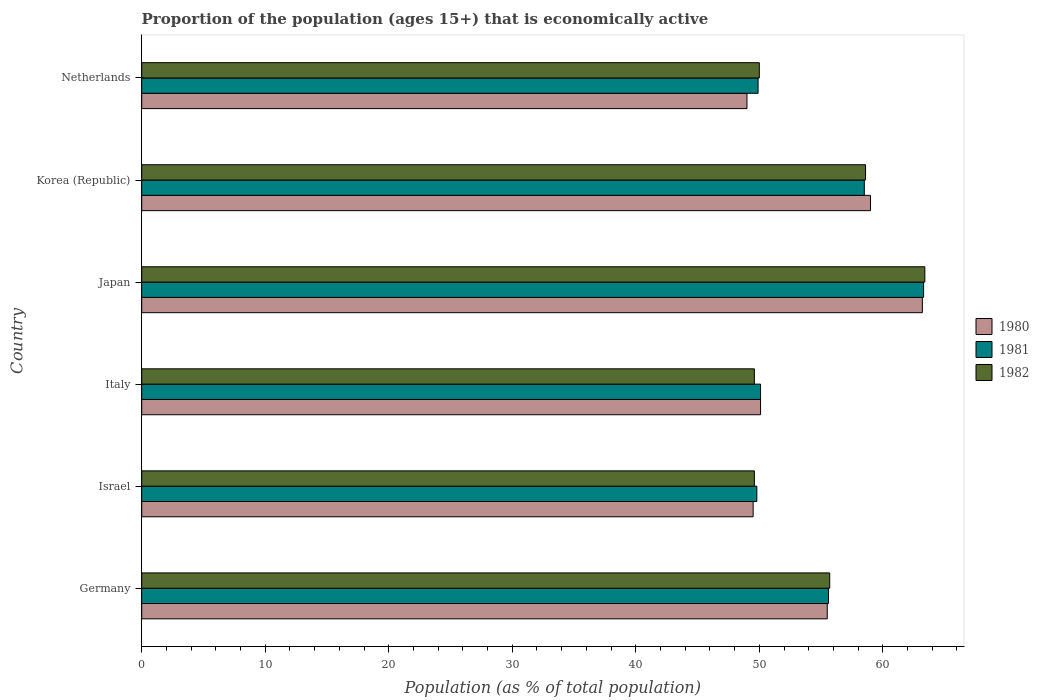How many different coloured bars are there?
Ensure brevity in your answer.  3. Are the number of bars on each tick of the Y-axis equal?
Offer a terse response. Yes. How many bars are there on the 3rd tick from the top?
Your answer should be compact. 3. What is the label of the 5th group of bars from the top?
Offer a terse response. Israel. In how many cases, is the number of bars for a given country not equal to the number of legend labels?
Provide a succinct answer. 0. What is the proportion of the population that is economically active in 1980 in Israel?
Provide a succinct answer. 49.5. Across all countries, what is the maximum proportion of the population that is economically active in 1981?
Provide a succinct answer. 63.3. Across all countries, what is the minimum proportion of the population that is economically active in 1981?
Your answer should be very brief. 49.8. In which country was the proportion of the population that is economically active in 1981 maximum?
Your answer should be compact. Japan. What is the total proportion of the population that is economically active in 1981 in the graph?
Provide a short and direct response. 327.2. What is the difference between the proportion of the population that is economically active in 1981 in Italy and that in Japan?
Give a very brief answer. -13.2. What is the difference between the proportion of the population that is economically active in 1981 in Netherlands and the proportion of the population that is economically active in 1980 in Italy?
Your answer should be very brief. -0.2. What is the average proportion of the population that is economically active in 1982 per country?
Offer a terse response. 54.48. What is the difference between the proportion of the population that is economically active in 1982 and proportion of the population that is economically active in 1980 in Japan?
Provide a succinct answer. 0.2. What is the ratio of the proportion of the population that is economically active in 1982 in Italy to that in Korea (Republic)?
Your answer should be compact. 0.85. Is the difference between the proportion of the population that is economically active in 1982 in Germany and Israel greater than the difference between the proportion of the population that is economically active in 1980 in Germany and Israel?
Your answer should be very brief. Yes. What is the difference between the highest and the second highest proportion of the population that is economically active in 1982?
Your answer should be very brief. 4.8. What is the difference between the highest and the lowest proportion of the population that is economically active in 1981?
Your answer should be very brief. 13.5. In how many countries, is the proportion of the population that is economically active in 1982 greater than the average proportion of the population that is economically active in 1982 taken over all countries?
Keep it short and to the point. 3. Is it the case that in every country, the sum of the proportion of the population that is economically active in 1980 and proportion of the population that is economically active in 1982 is greater than the proportion of the population that is economically active in 1981?
Provide a short and direct response. Yes. How many bars are there?
Provide a short and direct response. 18. How many countries are there in the graph?
Ensure brevity in your answer.  6. What is the difference between two consecutive major ticks on the X-axis?
Your answer should be compact. 10. Are the values on the major ticks of X-axis written in scientific E-notation?
Provide a short and direct response. No. How are the legend labels stacked?
Offer a very short reply. Vertical. What is the title of the graph?
Your answer should be compact. Proportion of the population (ages 15+) that is economically active. What is the label or title of the X-axis?
Make the answer very short. Population (as % of total population). What is the Population (as % of total population) in 1980 in Germany?
Offer a very short reply. 55.5. What is the Population (as % of total population) of 1981 in Germany?
Offer a very short reply. 55.6. What is the Population (as % of total population) in 1982 in Germany?
Provide a succinct answer. 55.7. What is the Population (as % of total population) of 1980 in Israel?
Keep it short and to the point. 49.5. What is the Population (as % of total population) in 1981 in Israel?
Offer a very short reply. 49.8. What is the Population (as % of total population) in 1982 in Israel?
Give a very brief answer. 49.6. What is the Population (as % of total population) of 1980 in Italy?
Ensure brevity in your answer.  50.1. What is the Population (as % of total population) of 1981 in Italy?
Make the answer very short. 50.1. What is the Population (as % of total population) in 1982 in Italy?
Provide a short and direct response. 49.6. What is the Population (as % of total population) of 1980 in Japan?
Keep it short and to the point. 63.2. What is the Population (as % of total population) in 1981 in Japan?
Provide a short and direct response. 63.3. What is the Population (as % of total population) in 1982 in Japan?
Give a very brief answer. 63.4. What is the Population (as % of total population) in 1980 in Korea (Republic)?
Your answer should be compact. 59. What is the Population (as % of total population) of 1981 in Korea (Republic)?
Your response must be concise. 58.5. What is the Population (as % of total population) in 1982 in Korea (Republic)?
Ensure brevity in your answer.  58.6. What is the Population (as % of total population) of 1980 in Netherlands?
Ensure brevity in your answer.  49. What is the Population (as % of total population) of 1981 in Netherlands?
Your response must be concise. 49.9. Across all countries, what is the maximum Population (as % of total population) in 1980?
Provide a succinct answer. 63.2. Across all countries, what is the maximum Population (as % of total population) in 1981?
Give a very brief answer. 63.3. Across all countries, what is the maximum Population (as % of total population) in 1982?
Give a very brief answer. 63.4. Across all countries, what is the minimum Population (as % of total population) in 1981?
Ensure brevity in your answer.  49.8. Across all countries, what is the minimum Population (as % of total population) of 1982?
Make the answer very short. 49.6. What is the total Population (as % of total population) in 1980 in the graph?
Keep it short and to the point. 326.3. What is the total Population (as % of total population) in 1981 in the graph?
Provide a short and direct response. 327.2. What is the total Population (as % of total population) in 1982 in the graph?
Offer a terse response. 326.9. What is the difference between the Population (as % of total population) in 1980 in Germany and that in Israel?
Provide a succinct answer. 6. What is the difference between the Population (as % of total population) of 1981 in Germany and that in Israel?
Ensure brevity in your answer.  5.8. What is the difference between the Population (as % of total population) in 1981 in Germany and that in Italy?
Your answer should be compact. 5.5. What is the difference between the Population (as % of total population) in 1982 in Germany and that in Italy?
Your answer should be very brief. 6.1. What is the difference between the Population (as % of total population) of 1981 in Germany and that in Japan?
Your response must be concise. -7.7. What is the difference between the Population (as % of total population) in 1980 in Germany and that in Korea (Republic)?
Keep it short and to the point. -3.5. What is the difference between the Population (as % of total population) in 1982 in Germany and that in Netherlands?
Your answer should be compact. 5.7. What is the difference between the Population (as % of total population) in 1981 in Israel and that in Italy?
Offer a very short reply. -0.3. What is the difference between the Population (as % of total population) of 1982 in Israel and that in Italy?
Give a very brief answer. 0. What is the difference between the Population (as % of total population) in 1980 in Israel and that in Japan?
Your answer should be compact. -13.7. What is the difference between the Population (as % of total population) of 1981 in Israel and that in Japan?
Your response must be concise. -13.5. What is the difference between the Population (as % of total population) of 1980 in Israel and that in Korea (Republic)?
Provide a short and direct response. -9.5. What is the difference between the Population (as % of total population) of 1981 in Israel and that in Korea (Republic)?
Ensure brevity in your answer.  -8.7. What is the difference between the Population (as % of total population) in 1980 in Israel and that in Netherlands?
Your response must be concise. 0.5. What is the difference between the Population (as % of total population) of 1981 in Israel and that in Netherlands?
Ensure brevity in your answer.  -0.1. What is the difference between the Population (as % of total population) in 1982 in Israel and that in Netherlands?
Offer a terse response. -0.4. What is the difference between the Population (as % of total population) of 1981 in Italy and that in Japan?
Give a very brief answer. -13.2. What is the difference between the Population (as % of total population) of 1982 in Italy and that in Japan?
Provide a short and direct response. -13.8. What is the difference between the Population (as % of total population) of 1980 in Italy and that in Netherlands?
Your answer should be compact. 1.1. What is the difference between the Population (as % of total population) in 1981 in Italy and that in Netherlands?
Your answer should be compact. 0.2. What is the difference between the Population (as % of total population) of 1980 in Korea (Republic) and that in Netherlands?
Your answer should be compact. 10. What is the difference between the Population (as % of total population) in 1982 in Korea (Republic) and that in Netherlands?
Provide a succinct answer. 8.6. What is the difference between the Population (as % of total population) in 1980 in Germany and the Population (as % of total population) in 1982 in Israel?
Make the answer very short. 5.9. What is the difference between the Population (as % of total population) in 1980 in Germany and the Population (as % of total population) in 1981 in Italy?
Your answer should be compact. 5.4. What is the difference between the Population (as % of total population) of 1980 in Germany and the Population (as % of total population) of 1982 in Japan?
Your answer should be compact. -7.9. What is the difference between the Population (as % of total population) in 1980 in Germany and the Population (as % of total population) in 1981 in Korea (Republic)?
Give a very brief answer. -3. What is the difference between the Population (as % of total population) of 1980 in Germany and the Population (as % of total population) of 1982 in Korea (Republic)?
Offer a very short reply. -3.1. What is the difference between the Population (as % of total population) of 1980 in Germany and the Population (as % of total population) of 1982 in Netherlands?
Your answer should be very brief. 5.5. What is the difference between the Population (as % of total population) of 1980 in Israel and the Population (as % of total population) of 1982 in Italy?
Offer a terse response. -0.1. What is the difference between the Population (as % of total population) in 1980 in Israel and the Population (as % of total population) in 1981 in Japan?
Provide a succinct answer. -13.8. What is the difference between the Population (as % of total population) of 1981 in Israel and the Population (as % of total population) of 1982 in Japan?
Provide a succinct answer. -13.6. What is the difference between the Population (as % of total population) of 1980 in Israel and the Population (as % of total population) of 1981 in Korea (Republic)?
Offer a terse response. -9. What is the difference between the Population (as % of total population) in 1980 in Israel and the Population (as % of total population) in 1982 in Netherlands?
Offer a very short reply. -0.5. What is the difference between the Population (as % of total population) of 1980 in Italy and the Population (as % of total population) of 1982 in Japan?
Your answer should be very brief. -13.3. What is the difference between the Population (as % of total population) of 1981 in Italy and the Population (as % of total population) of 1982 in Japan?
Your answer should be compact. -13.3. What is the difference between the Population (as % of total population) of 1980 in Italy and the Population (as % of total population) of 1981 in Korea (Republic)?
Offer a terse response. -8.4. What is the difference between the Population (as % of total population) of 1980 in Italy and the Population (as % of total population) of 1982 in Korea (Republic)?
Your answer should be very brief. -8.5. What is the difference between the Population (as % of total population) of 1981 in Italy and the Population (as % of total population) of 1982 in Korea (Republic)?
Ensure brevity in your answer.  -8.5. What is the difference between the Population (as % of total population) in 1980 in Italy and the Population (as % of total population) in 1981 in Netherlands?
Offer a very short reply. 0.2. What is the difference between the Population (as % of total population) of 1981 in Japan and the Population (as % of total population) of 1982 in Korea (Republic)?
Your response must be concise. 4.7. What is the difference between the Population (as % of total population) of 1980 in Japan and the Population (as % of total population) of 1982 in Netherlands?
Provide a succinct answer. 13.2. What is the difference between the Population (as % of total population) in 1980 in Korea (Republic) and the Population (as % of total population) in 1982 in Netherlands?
Keep it short and to the point. 9. What is the difference between the Population (as % of total population) in 1981 in Korea (Republic) and the Population (as % of total population) in 1982 in Netherlands?
Provide a short and direct response. 8.5. What is the average Population (as % of total population) of 1980 per country?
Your response must be concise. 54.38. What is the average Population (as % of total population) of 1981 per country?
Offer a terse response. 54.53. What is the average Population (as % of total population) of 1982 per country?
Keep it short and to the point. 54.48. What is the difference between the Population (as % of total population) of 1980 and Population (as % of total population) of 1982 in Germany?
Your answer should be compact. -0.2. What is the difference between the Population (as % of total population) in 1980 and Population (as % of total population) in 1981 in Israel?
Offer a terse response. -0.3. What is the difference between the Population (as % of total population) of 1980 and Population (as % of total population) of 1982 in Israel?
Make the answer very short. -0.1. What is the difference between the Population (as % of total population) of 1980 and Population (as % of total population) of 1981 in Italy?
Provide a succinct answer. 0. What is the difference between the Population (as % of total population) in 1981 and Population (as % of total population) in 1982 in Korea (Republic)?
Ensure brevity in your answer.  -0.1. What is the difference between the Population (as % of total population) of 1980 and Population (as % of total population) of 1982 in Netherlands?
Offer a very short reply. -1. What is the ratio of the Population (as % of total population) in 1980 in Germany to that in Israel?
Your response must be concise. 1.12. What is the ratio of the Population (as % of total population) in 1981 in Germany to that in Israel?
Give a very brief answer. 1.12. What is the ratio of the Population (as % of total population) in 1982 in Germany to that in Israel?
Your response must be concise. 1.12. What is the ratio of the Population (as % of total population) in 1980 in Germany to that in Italy?
Provide a succinct answer. 1.11. What is the ratio of the Population (as % of total population) of 1981 in Germany to that in Italy?
Ensure brevity in your answer.  1.11. What is the ratio of the Population (as % of total population) in 1982 in Germany to that in Italy?
Provide a short and direct response. 1.12. What is the ratio of the Population (as % of total population) in 1980 in Germany to that in Japan?
Ensure brevity in your answer.  0.88. What is the ratio of the Population (as % of total population) in 1981 in Germany to that in Japan?
Provide a succinct answer. 0.88. What is the ratio of the Population (as % of total population) in 1982 in Germany to that in Japan?
Your answer should be compact. 0.88. What is the ratio of the Population (as % of total population) in 1980 in Germany to that in Korea (Republic)?
Offer a terse response. 0.94. What is the ratio of the Population (as % of total population) of 1981 in Germany to that in Korea (Republic)?
Give a very brief answer. 0.95. What is the ratio of the Population (as % of total population) of 1982 in Germany to that in Korea (Republic)?
Ensure brevity in your answer.  0.95. What is the ratio of the Population (as % of total population) of 1980 in Germany to that in Netherlands?
Give a very brief answer. 1.13. What is the ratio of the Population (as % of total population) of 1981 in Germany to that in Netherlands?
Your response must be concise. 1.11. What is the ratio of the Population (as % of total population) in 1982 in Germany to that in Netherlands?
Give a very brief answer. 1.11. What is the ratio of the Population (as % of total population) of 1982 in Israel to that in Italy?
Your response must be concise. 1. What is the ratio of the Population (as % of total population) in 1980 in Israel to that in Japan?
Make the answer very short. 0.78. What is the ratio of the Population (as % of total population) in 1981 in Israel to that in Japan?
Give a very brief answer. 0.79. What is the ratio of the Population (as % of total population) in 1982 in Israel to that in Japan?
Your response must be concise. 0.78. What is the ratio of the Population (as % of total population) of 1980 in Israel to that in Korea (Republic)?
Offer a very short reply. 0.84. What is the ratio of the Population (as % of total population) of 1981 in Israel to that in Korea (Republic)?
Provide a short and direct response. 0.85. What is the ratio of the Population (as % of total population) of 1982 in Israel to that in Korea (Republic)?
Provide a succinct answer. 0.85. What is the ratio of the Population (as % of total population) in 1980 in Israel to that in Netherlands?
Provide a succinct answer. 1.01. What is the ratio of the Population (as % of total population) in 1980 in Italy to that in Japan?
Give a very brief answer. 0.79. What is the ratio of the Population (as % of total population) of 1981 in Italy to that in Japan?
Provide a short and direct response. 0.79. What is the ratio of the Population (as % of total population) in 1982 in Italy to that in Japan?
Give a very brief answer. 0.78. What is the ratio of the Population (as % of total population) of 1980 in Italy to that in Korea (Republic)?
Your answer should be compact. 0.85. What is the ratio of the Population (as % of total population) of 1981 in Italy to that in Korea (Republic)?
Provide a succinct answer. 0.86. What is the ratio of the Population (as % of total population) in 1982 in Italy to that in Korea (Republic)?
Provide a short and direct response. 0.85. What is the ratio of the Population (as % of total population) in 1980 in Italy to that in Netherlands?
Provide a short and direct response. 1.02. What is the ratio of the Population (as % of total population) in 1982 in Italy to that in Netherlands?
Provide a short and direct response. 0.99. What is the ratio of the Population (as % of total population) of 1980 in Japan to that in Korea (Republic)?
Provide a short and direct response. 1.07. What is the ratio of the Population (as % of total population) of 1981 in Japan to that in Korea (Republic)?
Give a very brief answer. 1.08. What is the ratio of the Population (as % of total population) in 1982 in Japan to that in Korea (Republic)?
Your answer should be very brief. 1.08. What is the ratio of the Population (as % of total population) in 1980 in Japan to that in Netherlands?
Ensure brevity in your answer.  1.29. What is the ratio of the Population (as % of total population) in 1981 in Japan to that in Netherlands?
Keep it short and to the point. 1.27. What is the ratio of the Population (as % of total population) of 1982 in Japan to that in Netherlands?
Provide a short and direct response. 1.27. What is the ratio of the Population (as % of total population) of 1980 in Korea (Republic) to that in Netherlands?
Provide a short and direct response. 1.2. What is the ratio of the Population (as % of total population) of 1981 in Korea (Republic) to that in Netherlands?
Your response must be concise. 1.17. What is the ratio of the Population (as % of total population) of 1982 in Korea (Republic) to that in Netherlands?
Keep it short and to the point. 1.17. What is the difference between the highest and the lowest Population (as % of total population) of 1981?
Keep it short and to the point. 13.5. What is the difference between the highest and the lowest Population (as % of total population) of 1982?
Give a very brief answer. 13.8. 